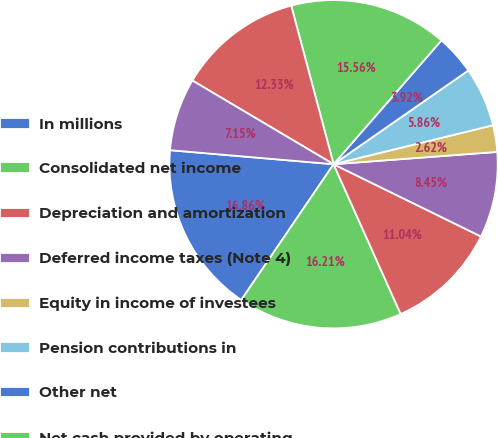Convert chart to OTSL. <chart><loc_0><loc_0><loc_500><loc_500><pie_chart><fcel>In millions<fcel>Consolidated net income<fcel>Depreciation and amortization<fcel>Deferred income taxes (Note 4)<fcel>Equity in income of investees<fcel>Pension contributions in<fcel>Other net<fcel>Net cash provided by operating<fcel>Capital expenditures<fcel>Investments in internal use<nl><fcel>16.86%<fcel>16.21%<fcel>11.04%<fcel>8.45%<fcel>2.62%<fcel>5.86%<fcel>3.92%<fcel>15.56%<fcel>12.33%<fcel>7.15%<nl></chart> 